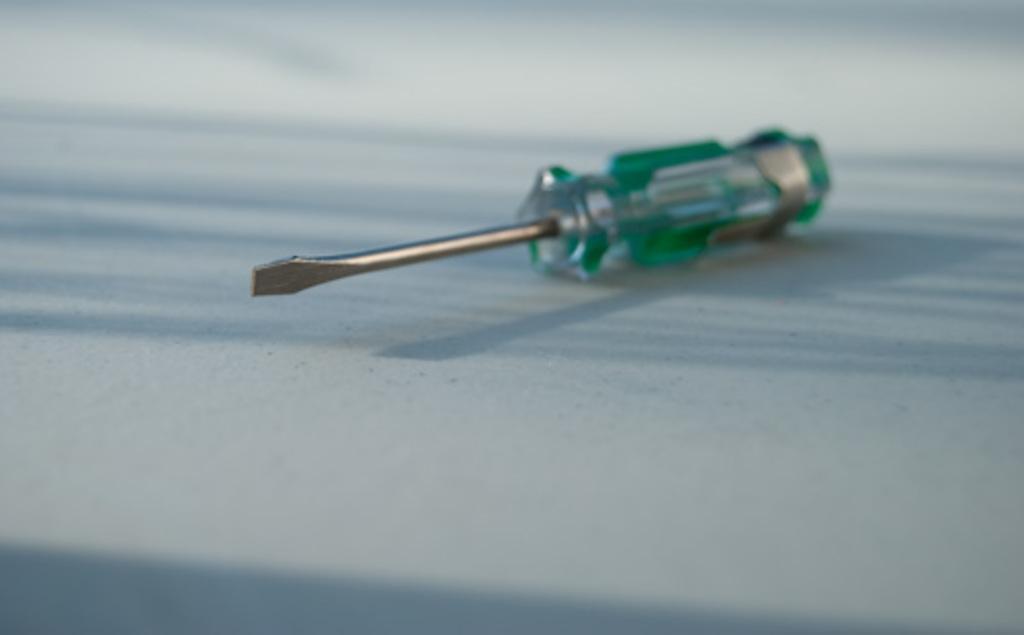Describe this image in one or two sentences. This image consists of a screw driver kept on the floor. 